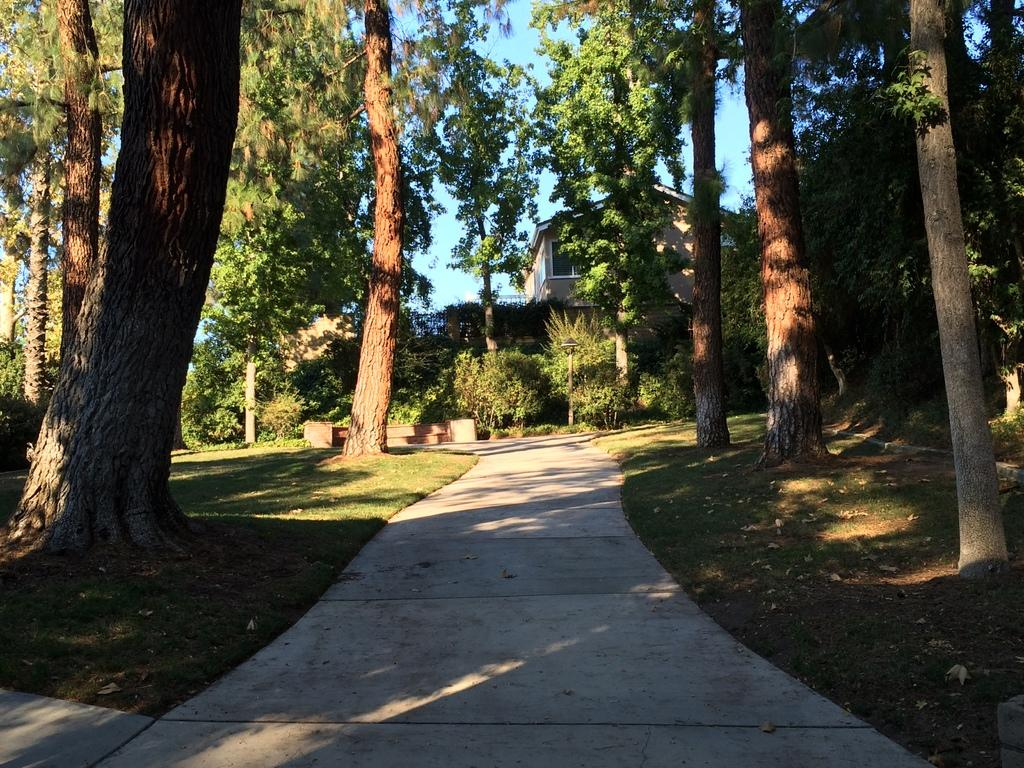What type of vegetation can be seen in the image? There is grass, plants, and trees in the image. What type of structures are present in the image? There are buildings in the image. What part of the natural environment is visible in the image? The sky is visible in the image. Where is the throne located in the image? There is no throne present in the image. What type of oil can be seen dripping from the trees in the image? There is no oil present in the image; it features grass, plants, trees, buildings, and the sky. 